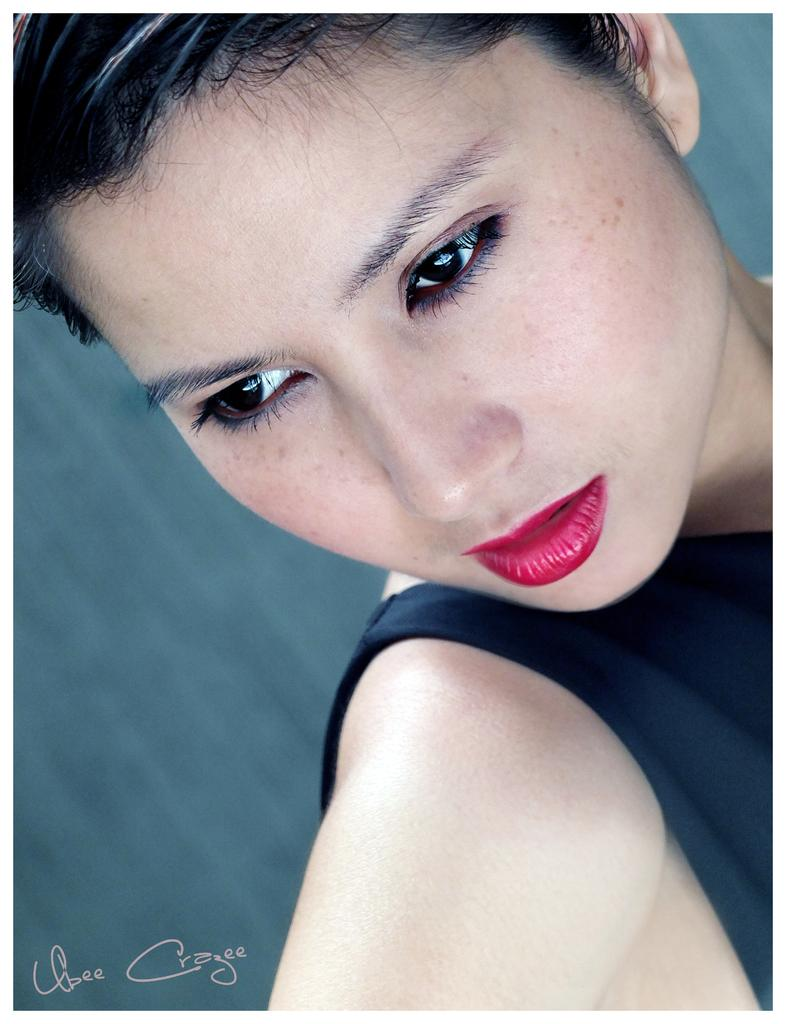Who is the main subject in the image? There is a lady in the center of the image. What else can be seen at the bottom of the image? There is some text at the bottom of the image. How many apples are being used as a wrench in the image? There are no apples or wrenches present in the image. 